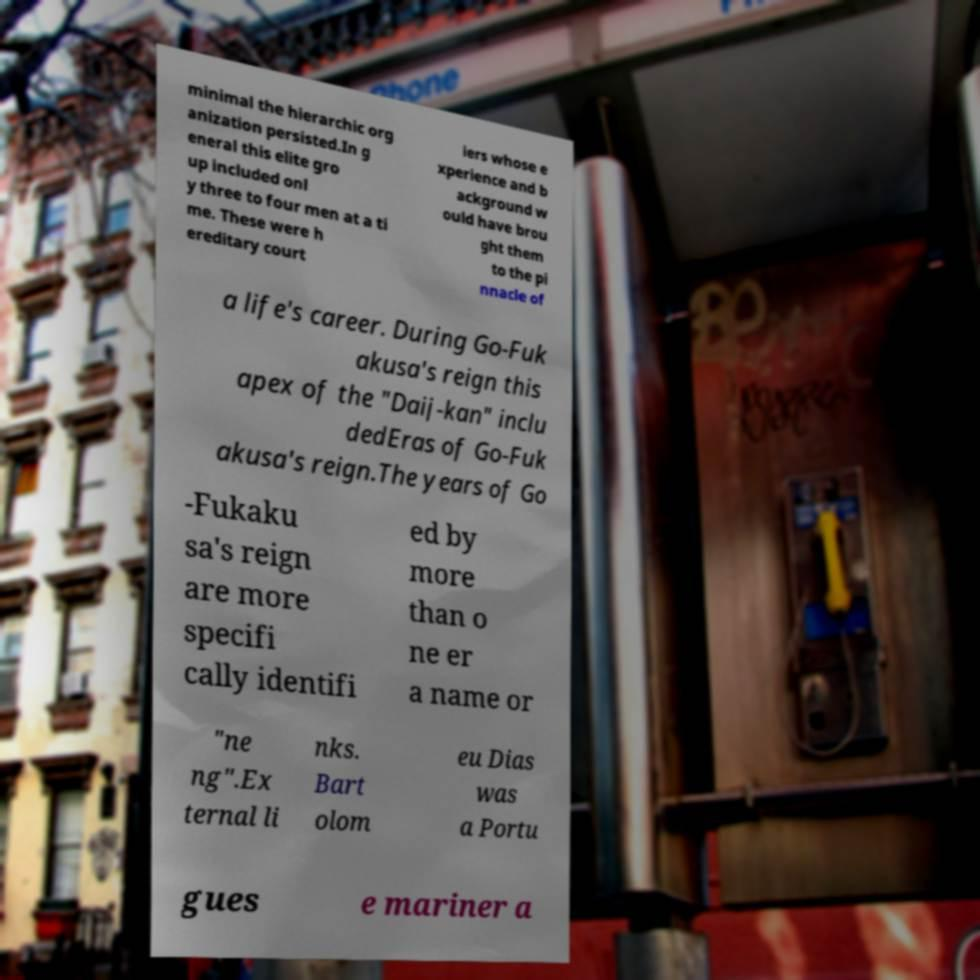Can you read and provide the text displayed in the image?This photo seems to have some interesting text. Can you extract and type it out for me? minimal the hierarchic org anization persisted.In g eneral this elite gro up included onl y three to four men at a ti me. These were h ereditary court iers whose e xperience and b ackground w ould have brou ght them to the pi nnacle of a life's career. During Go-Fuk akusa's reign this apex of the "Daij-kan" inclu dedEras of Go-Fuk akusa's reign.The years of Go -Fukaku sa's reign are more specifi cally identifi ed by more than o ne er a name or "ne ng".Ex ternal li nks. Bart olom eu Dias was a Portu gues e mariner a 